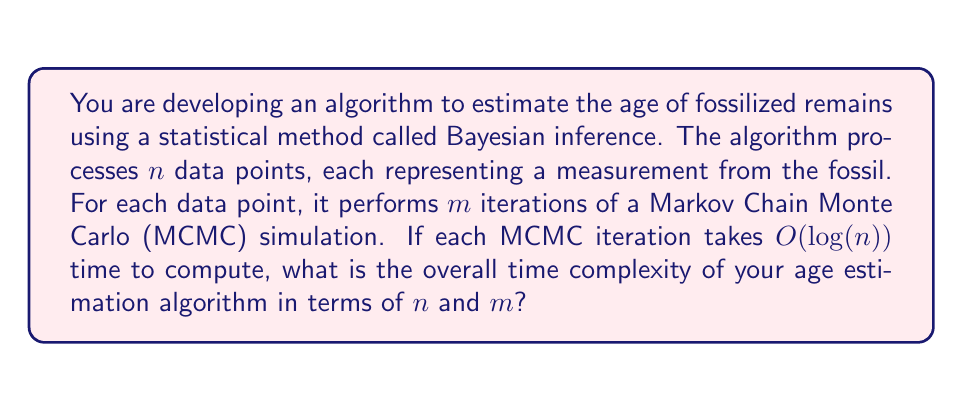Solve this math problem. To determine the overall time complexity of the age estimation algorithm, we need to analyze its structure and the operations involved:

1. The algorithm processes $n$ data points.
2. For each data point, it performs $m$ iterations of MCMC simulation.
3. Each MCMC iteration takes $O(log(n))$ time to compute.

Let's break down the complexity analysis:

1. The outermost operation is processing $n$ data points, which gives us a factor of $n$.
2. For each of these $n$ data points, we perform $m$ iterations of MCMC, adding another factor of $m$.
3. Each MCMC iteration has a time complexity of $O(log(n))$.

Combining these factors, we get:

$$n \times m \times O(log(n))$$

This can be simplified to:

$$O(n \times m \times log(n))$$

This expression represents the overall time complexity of the algorithm. It shows that the time taken grows linearly with both $n$ (the number of data points) and $m$ (the number of MCMC iterations), and logarithmically with $n$ due to the complexity of each MCMC iteration.
Answer: $O(n \times m \times log(n))$ 